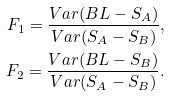<formula> <loc_0><loc_0><loc_500><loc_500>F _ { 1 } = \frac { V a r ( B L - S _ { A } ) } { V a r ( S _ { A } - S _ { B } ) } , \\ F _ { 2 } = \frac { V a r ( B L - S _ { B } ) } { V a r ( S _ { A } - S _ { B } ) } .</formula> 